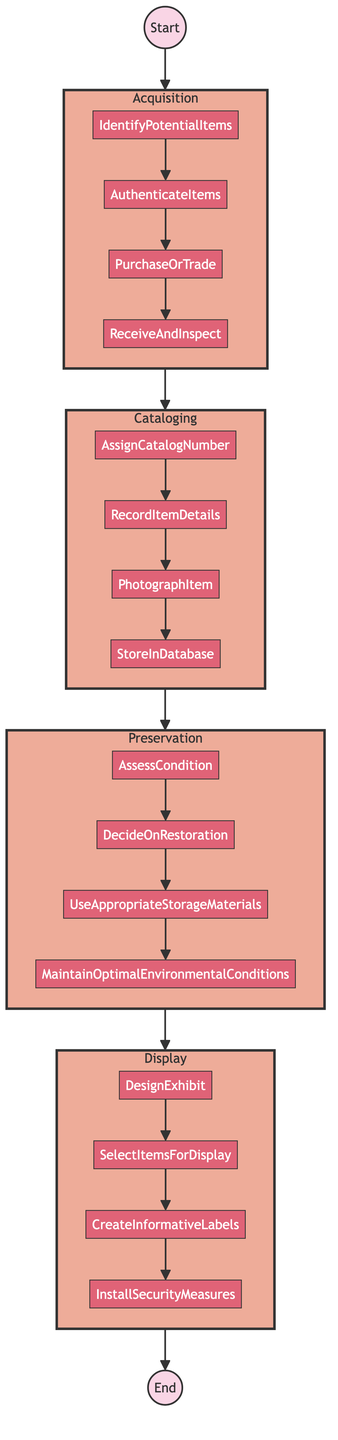What is the first step in the process? The diagram indicates that the flow starts from the "Acquisition" step. Following the flow from "Start" to the first node, we can see "Acquisition" is directly connected.
Answer: Acquisition How many steps are there in the process? The diagram includes four distinct steps: Acquisition, Cataloging, Preservation, and Display, all of which are listed in a sequential manner.
Answer: Four Which step involves creating detailed records? The "Cataloging" step is specifically focused on creating detailed records as indicated in its description within the diagram.
Answer: Cataloging What action directly follows "AuthenticateItems" in the Acquisition step? In the flowchart, after "AuthenticateItems," the next connected action is "PurchaseOrTrade," showing the sequential order of activities within the Acquisition step.
Answer: PurchaseOrTrade How many actions are listed under the Preservation step? The "Preservation" step has four actions: Assess Condition, Decide On Restoration, Use Appropriate Storage Materials, and Maintain Optimal Environmental Conditions, which can be counted from the diagram.
Answer: Four What is the last action performed in the Display step? According to the diagram, the final action in the "Display" step is "Install Security Measures," showing the last stage of exhibiting items.
Answer: Install Security Measures Which action is performed after "PhotographItem" during Cataloging? In the sequence of actions within the "Cataloging" step, the action following "PhotographItem" is "Store In Database," establishing the order within this part of the process.
Answer: Store In Database What is the overall purpose of the flowchart? The flowchart visually represents the entire process of "Cataloging and Preserving Film Memorabilia," detailing the steps and actions involved from start to finish.
Answer: Cataloging and Preserving Film Memorabilia 